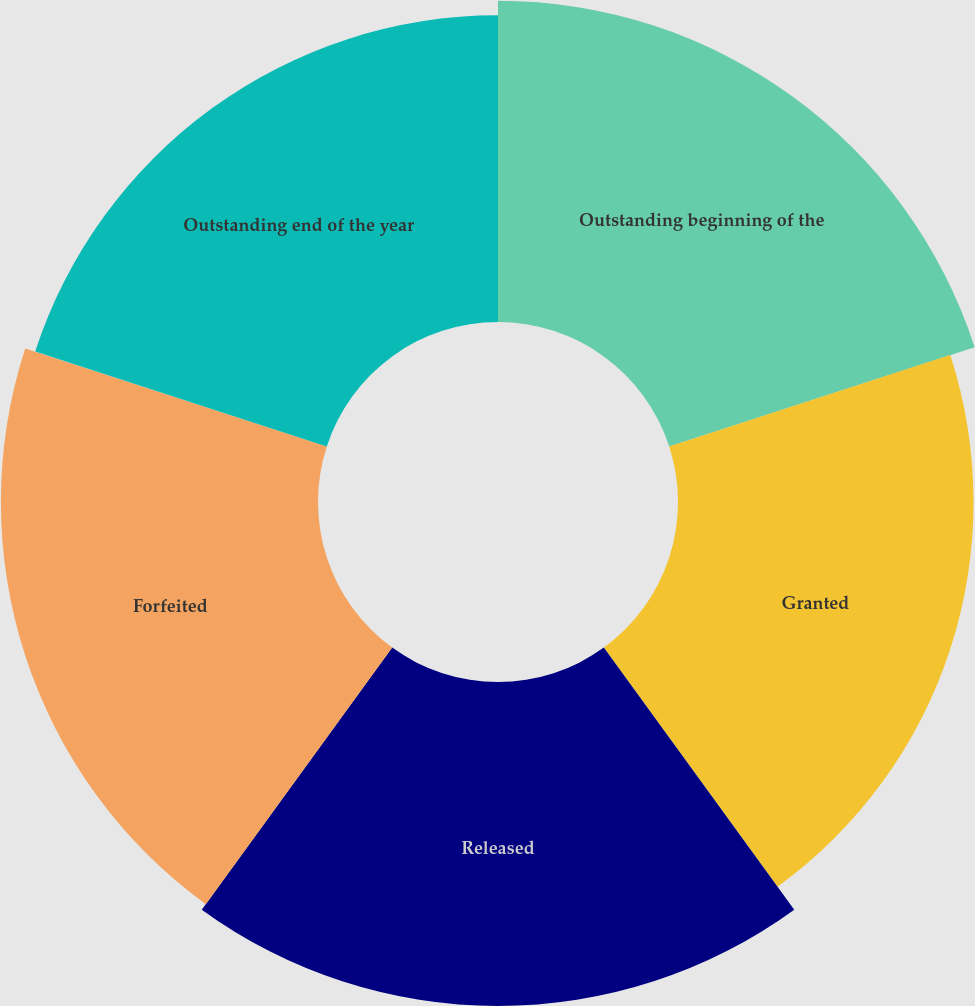Convert chart to OTSL. <chart><loc_0><loc_0><loc_500><loc_500><pie_chart><fcel>Outstanding beginning of the<fcel>Granted<fcel>Released<fcel>Forfeited<fcel>Outstanding end of the year<nl><fcel>20.53%<fcel>18.89%<fcel>20.71%<fcel>20.27%<fcel>19.6%<nl></chart> 